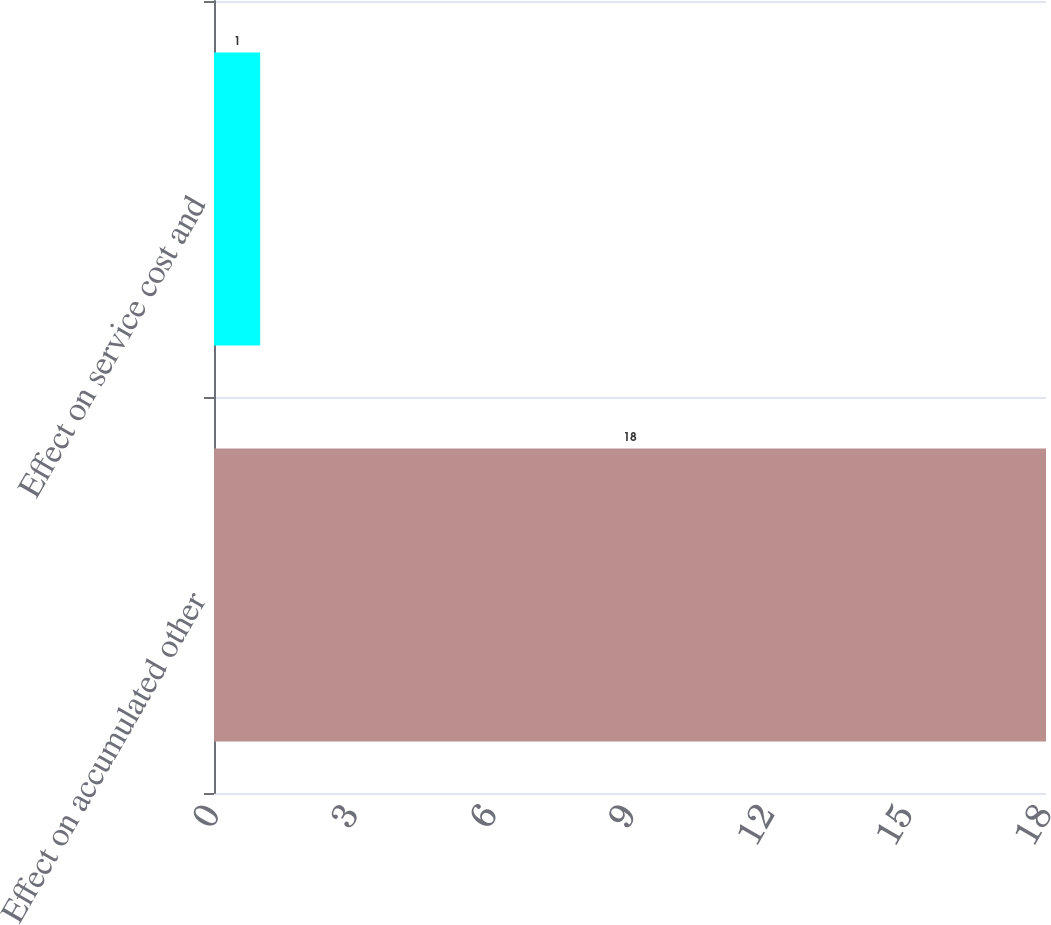<chart> <loc_0><loc_0><loc_500><loc_500><bar_chart><fcel>Effect on accumulated other<fcel>Effect on service cost and<nl><fcel>18<fcel>1<nl></chart> 